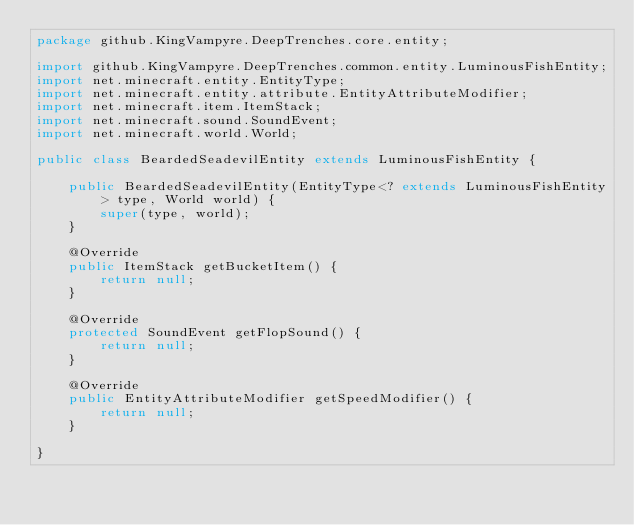<code> <loc_0><loc_0><loc_500><loc_500><_Java_>package github.KingVampyre.DeepTrenches.core.entity;

import github.KingVampyre.DeepTrenches.common.entity.LuminousFishEntity;
import net.minecraft.entity.EntityType;
import net.minecraft.entity.attribute.EntityAttributeModifier;
import net.minecraft.item.ItemStack;
import net.minecraft.sound.SoundEvent;
import net.minecraft.world.World;

public class BeardedSeadevilEntity extends LuminousFishEntity {

    public BeardedSeadevilEntity(EntityType<? extends LuminousFishEntity> type, World world) {
        super(type, world);
    }

    @Override
    public ItemStack getBucketItem() {
        return null;
    }

    @Override
    protected SoundEvent getFlopSound() {
        return null;
    }

    @Override
    public EntityAttributeModifier getSpeedModifier() {
        return null;
    }

}
</code> 